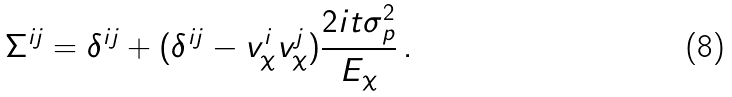Convert formula to latex. <formula><loc_0><loc_0><loc_500><loc_500>\Sigma ^ { i j } = \delta ^ { i j } + ( \delta ^ { i j } - v _ { \chi } ^ { i } v _ { \chi } ^ { j } ) \frac { 2 i t \sigma _ { p } ^ { 2 } } { E _ { \chi } } \, .</formula> 